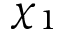Convert formula to latex. <formula><loc_0><loc_0><loc_500><loc_500>\chi _ { 1 }</formula> 